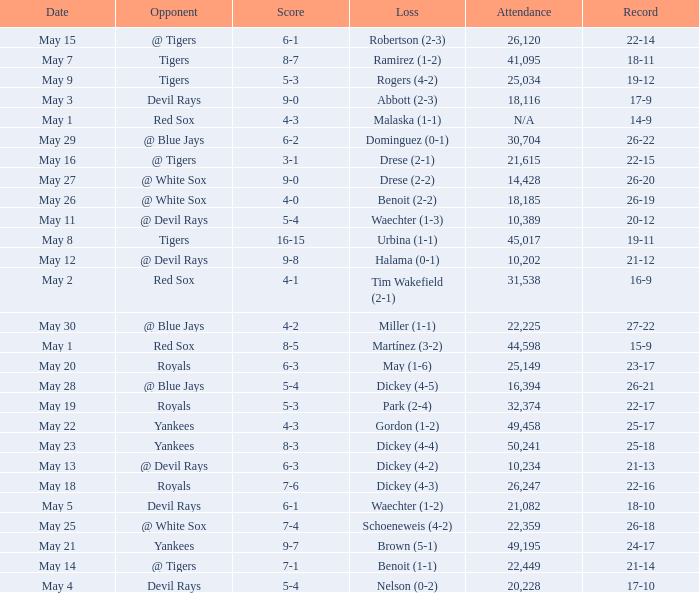What was the score of the game that had a loss of Drese (2-2)? 9-0. 